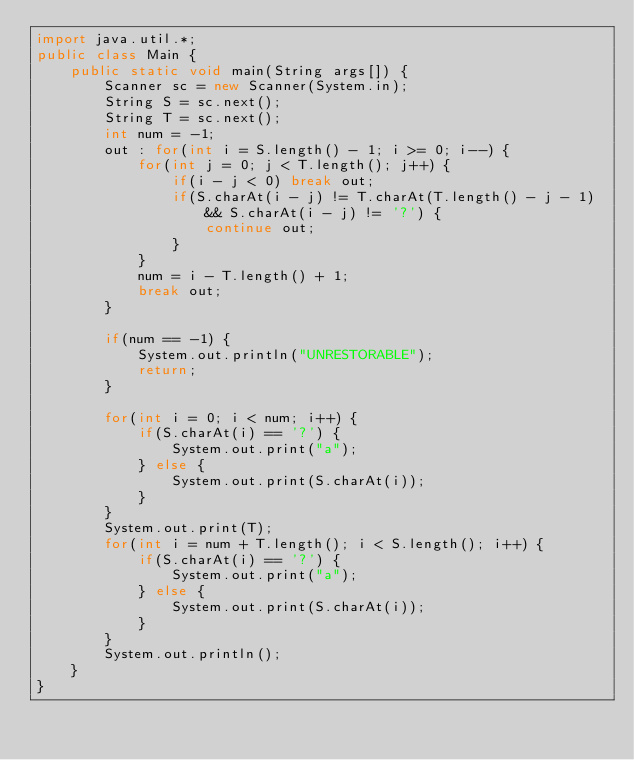<code> <loc_0><loc_0><loc_500><loc_500><_Java_>import java.util.*;
public class Main {
	public static void main(String args[]) {
		Scanner sc = new Scanner(System.in);
		String S = sc.next();
		String T = sc.next();
		int num = -1;
		out : for(int i = S.length() - 1; i >= 0; i--) {
			for(int j = 0; j < T.length(); j++) {
				if(i - j < 0) break out;
				if(S.charAt(i - j) != T.charAt(T.length() - j - 1) && S.charAt(i - j) != '?') {
					continue out;
				}
			}
			num = i - T.length() + 1;
			break out;
		}
		
		if(num == -1) {
			System.out.println("UNRESTORABLE");
			return;
		}
		
		for(int i = 0; i < num; i++) {
			if(S.charAt(i) == '?') {
				System.out.print("a");
			} else {
				System.out.print(S.charAt(i));
			}
		}
		System.out.print(T);
		for(int i = num + T.length(); i < S.length(); i++) {
			if(S.charAt(i) == '?') {
				System.out.print("a");
			} else {
				System.out.print(S.charAt(i));
			}
		}
		System.out.println();
	}
}
</code> 